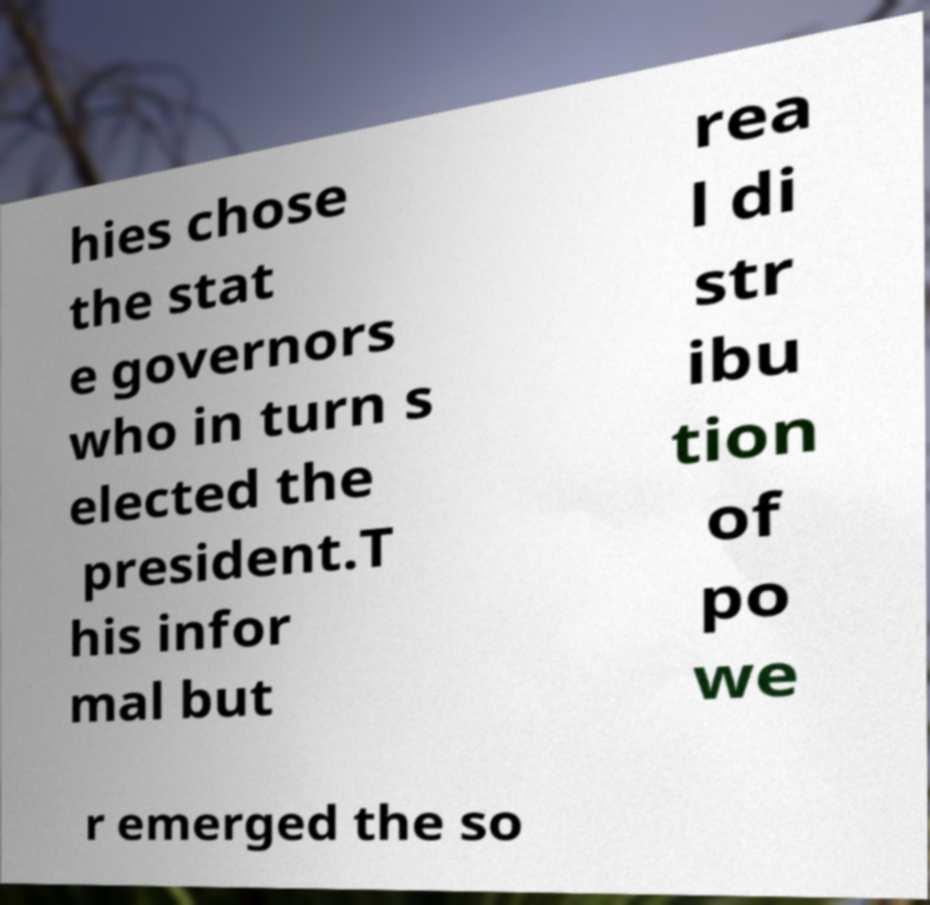Please read and relay the text visible in this image. What does it say? hies chose the stat e governors who in turn s elected the president.T his infor mal but rea l di str ibu tion of po we r emerged the so 